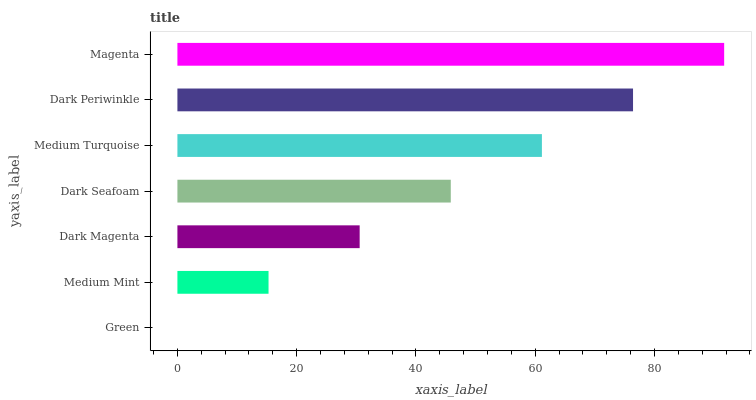Is Green the minimum?
Answer yes or no. Yes. Is Magenta the maximum?
Answer yes or no. Yes. Is Medium Mint the minimum?
Answer yes or no. No. Is Medium Mint the maximum?
Answer yes or no. No. Is Medium Mint greater than Green?
Answer yes or no. Yes. Is Green less than Medium Mint?
Answer yes or no. Yes. Is Green greater than Medium Mint?
Answer yes or no. No. Is Medium Mint less than Green?
Answer yes or no. No. Is Dark Seafoam the high median?
Answer yes or no. Yes. Is Dark Seafoam the low median?
Answer yes or no. Yes. Is Green the high median?
Answer yes or no. No. Is Magenta the low median?
Answer yes or no. No. 